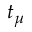<formula> <loc_0><loc_0><loc_500><loc_500>t _ { \mu }</formula> 